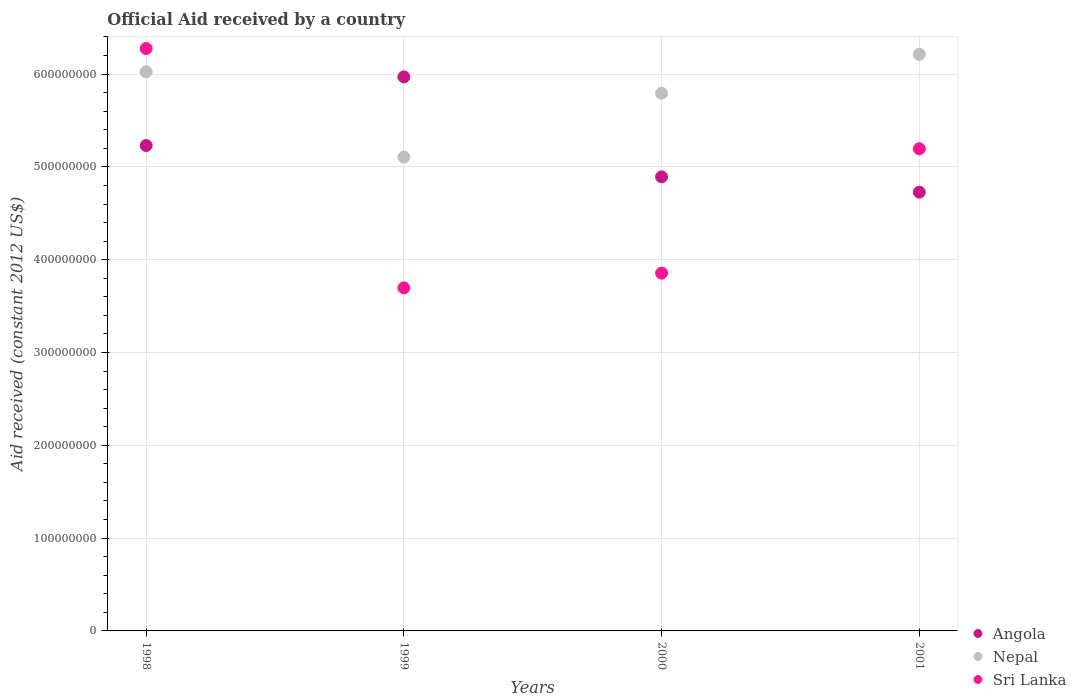What is the net official aid received in Angola in 2000?
Your answer should be compact. 4.89e+08. Across all years, what is the maximum net official aid received in Nepal?
Offer a terse response. 6.21e+08. Across all years, what is the minimum net official aid received in Sri Lanka?
Make the answer very short. 3.70e+08. In which year was the net official aid received in Sri Lanka maximum?
Make the answer very short. 1998. In which year was the net official aid received in Nepal minimum?
Your response must be concise. 1999. What is the total net official aid received in Nepal in the graph?
Your answer should be compact. 2.31e+09. What is the difference between the net official aid received in Nepal in 1998 and that in 2001?
Give a very brief answer. -1.89e+07. What is the difference between the net official aid received in Angola in 1998 and the net official aid received in Nepal in 2001?
Your answer should be compact. -9.83e+07. What is the average net official aid received in Angola per year?
Keep it short and to the point. 5.21e+08. In the year 2000, what is the difference between the net official aid received in Sri Lanka and net official aid received in Nepal?
Give a very brief answer. -1.94e+08. What is the ratio of the net official aid received in Sri Lanka in 1998 to that in 2001?
Make the answer very short. 1.21. What is the difference between the highest and the second highest net official aid received in Nepal?
Make the answer very short. 1.89e+07. What is the difference between the highest and the lowest net official aid received in Nepal?
Your answer should be very brief. 1.11e+08. Does the net official aid received in Sri Lanka monotonically increase over the years?
Make the answer very short. No. Is the net official aid received in Angola strictly less than the net official aid received in Sri Lanka over the years?
Provide a succinct answer. No. How many years are there in the graph?
Your response must be concise. 4. What is the difference between two consecutive major ticks on the Y-axis?
Your answer should be compact. 1.00e+08. Does the graph contain any zero values?
Ensure brevity in your answer.  No. Does the graph contain grids?
Your answer should be very brief. Yes. Where does the legend appear in the graph?
Offer a very short reply. Bottom right. How many legend labels are there?
Provide a succinct answer. 3. How are the legend labels stacked?
Your response must be concise. Vertical. What is the title of the graph?
Provide a short and direct response. Official Aid received by a country. What is the label or title of the Y-axis?
Give a very brief answer. Aid received (constant 2012 US$). What is the Aid received (constant 2012 US$) of Angola in 1998?
Your answer should be very brief. 5.23e+08. What is the Aid received (constant 2012 US$) in Nepal in 1998?
Keep it short and to the point. 6.02e+08. What is the Aid received (constant 2012 US$) of Sri Lanka in 1998?
Your answer should be compact. 6.28e+08. What is the Aid received (constant 2012 US$) in Angola in 1999?
Give a very brief answer. 5.97e+08. What is the Aid received (constant 2012 US$) in Nepal in 1999?
Provide a short and direct response. 5.11e+08. What is the Aid received (constant 2012 US$) in Sri Lanka in 1999?
Your response must be concise. 3.70e+08. What is the Aid received (constant 2012 US$) of Angola in 2000?
Give a very brief answer. 4.89e+08. What is the Aid received (constant 2012 US$) of Nepal in 2000?
Make the answer very short. 5.79e+08. What is the Aid received (constant 2012 US$) of Sri Lanka in 2000?
Offer a very short reply. 3.86e+08. What is the Aid received (constant 2012 US$) in Angola in 2001?
Make the answer very short. 4.73e+08. What is the Aid received (constant 2012 US$) of Nepal in 2001?
Give a very brief answer. 6.21e+08. What is the Aid received (constant 2012 US$) in Sri Lanka in 2001?
Your answer should be compact. 5.20e+08. Across all years, what is the maximum Aid received (constant 2012 US$) of Angola?
Offer a very short reply. 5.97e+08. Across all years, what is the maximum Aid received (constant 2012 US$) of Nepal?
Keep it short and to the point. 6.21e+08. Across all years, what is the maximum Aid received (constant 2012 US$) in Sri Lanka?
Offer a terse response. 6.28e+08. Across all years, what is the minimum Aid received (constant 2012 US$) in Angola?
Offer a very short reply. 4.73e+08. Across all years, what is the minimum Aid received (constant 2012 US$) of Nepal?
Make the answer very short. 5.11e+08. Across all years, what is the minimum Aid received (constant 2012 US$) of Sri Lanka?
Your answer should be very brief. 3.70e+08. What is the total Aid received (constant 2012 US$) of Angola in the graph?
Ensure brevity in your answer.  2.08e+09. What is the total Aid received (constant 2012 US$) of Nepal in the graph?
Make the answer very short. 2.31e+09. What is the total Aid received (constant 2012 US$) of Sri Lanka in the graph?
Offer a very short reply. 1.90e+09. What is the difference between the Aid received (constant 2012 US$) in Angola in 1998 and that in 1999?
Your response must be concise. -7.39e+07. What is the difference between the Aid received (constant 2012 US$) in Nepal in 1998 and that in 1999?
Your response must be concise. 9.19e+07. What is the difference between the Aid received (constant 2012 US$) of Sri Lanka in 1998 and that in 1999?
Give a very brief answer. 2.58e+08. What is the difference between the Aid received (constant 2012 US$) in Angola in 1998 and that in 2000?
Give a very brief answer. 3.38e+07. What is the difference between the Aid received (constant 2012 US$) of Nepal in 1998 and that in 2000?
Provide a succinct answer. 2.31e+07. What is the difference between the Aid received (constant 2012 US$) of Sri Lanka in 1998 and that in 2000?
Offer a terse response. 2.42e+08. What is the difference between the Aid received (constant 2012 US$) in Angola in 1998 and that in 2001?
Offer a very short reply. 5.03e+07. What is the difference between the Aid received (constant 2012 US$) in Nepal in 1998 and that in 2001?
Provide a succinct answer. -1.89e+07. What is the difference between the Aid received (constant 2012 US$) in Sri Lanka in 1998 and that in 2001?
Make the answer very short. 1.08e+08. What is the difference between the Aid received (constant 2012 US$) of Angola in 1999 and that in 2000?
Your response must be concise. 1.08e+08. What is the difference between the Aid received (constant 2012 US$) in Nepal in 1999 and that in 2000?
Offer a terse response. -6.88e+07. What is the difference between the Aid received (constant 2012 US$) of Sri Lanka in 1999 and that in 2000?
Ensure brevity in your answer.  -1.59e+07. What is the difference between the Aid received (constant 2012 US$) in Angola in 1999 and that in 2001?
Your answer should be compact. 1.24e+08. What is the difference between the Aid received (constant 2012 US$) in Nepal in 1999 and that in 2001?
Offer a very short reply. -1.11e+08. What is the difference between the Aid received (constant 2012 US$) of Sri Lanka in 1999 and that in 2001?
Keep it short and to the point. -1.50e+08. What is the difference between the Aid received (constant 2012 US$) in Angola in 2000 and that in 2001?
Your answer should be very brief. 1.65e+07. What is the difference between the Aid received (constant 2012 US$) in Nepal in 2000 and that in 2001?
Provide a succinct answer. -4.20e+07. What is the difference between the Aid received (constant 2012 US$) of Sri Lanka in 2000 and that in 2001?
Your answer should be very brief. -1.34e+08. What is the difference between the Aid received (constant 2012 US$) of Angola in 1998 and the Aid received (constant 2012 US$) of Nepal in 1999?
Offer a terse response. 1.25e+07. What is the difference between the Aid received (constant 2012 US$) in Angola in 1998 and the Aid received (constant 2012 US$) in Sri Lanka in 1999?
Make the answer very short. 1.53e+08. What is the difference between the Aid received (constant 2012 US$) of Nepal in 1998 and the Aid received (constant 2012 US$) of Sri Lanka in 1999?
Your answer should be very brief. 2.33e+08. What is the difference between the Aid received (constant 2012 US$) of Angola in 1998 and the Aid received (constant 2012 US$) of Nepal in 2000?
Offer a very short reply. -5.63e+07. What is the difference between the Aid received (constant 2012 US$) in Angola in 1998 and the Aid received (constant 2012 US$) in Sri Lanka in 2000?
Give a very brief answer. 1.38e+08. What is the difference between the Aid received (constant 2012 US$) of Nepal in 1998 and the Aid received (constant 2012 US$) of Sri Lanka in 2000?
Your answer should be compact. 2.17e+08. What is the difference between the Aid received (constant 2012 US$) in Angola in 1998 and the Aid received (constant 2012 US$) in Nepal in 2001?
Your answer should be very brief. -9.83e+07. What is the difference between the Aid received (constant 2012 US$) in Angola in 1998 and the Aid received (constant 2012 US$) in Sri Lanka in 2001?
Ensure brevity in your answer.  3.51e+06. What is the difference between the Aid received (constant 2012 US$) in Nepal in 1998 and the Aid received (constant 2012 US$) in Sri Lanka in 2001?
Offer a very short reply. 8.29e+07. What is the difference between the Aid received (constant 2012 US$) in Angola in 1999 and the Aid received (constant 2012 US$) in Nepal in 2000?
Keep it short and to the point. 1.76e+07. What is the difference between the Aid received (constant 2012 US$) of Angola in 1999 and the Aid received (constant 2012 US$) of Sri Lanka in 2000?
Make the answer very short. 2.11e+08. What is the difference between the Aid received (constant 2012 US$) of Nepal in 1999 and the Aid received (constant 2012 US$) of Sri Lanka in 2000?
Provide a short and direct response. 1.25e+08. What is the difference between the Aid received (constant 2012 US$) in Angola in 1999 and the Aid received (constant 2012 US$) in Nepal in 2001?
Keep it short and to the point. -2.44e+07. What is the difference between the Aid received (constant 2012 US$) in Angola in 1999 and the Aid received (constant 2012 US$) in Sri Lanka in 2001?
Your answer should be very brief. 7.74e+07. What is the difference between the Aid received (constant 2012 US$) in Nepal in 1999 and the Aid received (constant 2012 US$) in Sri Lanka in 2001?
Give a very brief answer. -8.98e+06. What is the difference between the Aid received (constant 2012 US$) in Angola in 2000 and the Aid received (constant 2012 US$) in Nepal in 2001?
Give a very brief answer. -1.32e+08. What is the difference between the Aid received (constant 2012 US$) in Angola in 2000 and the Aid received (constant 2012 US$) in Sri Lanka in 2001?
Keep it short and to the point. -3.02e+07. What is the difference between the Aid received (constant 2012 US$) in Nepal in 2000 and the Aid received (constant 2012 US$) in Sri Lanka in 2001?
Your answer should be very brief. 5.98e+07. What is the average Aid received (constant 2012 US$) in Angola per year?
Ensure brevity in your answer.  5.21e+08. What is the average Aid received (constant 2012 US$) of Nepal per year?
Provide a succinct answer. 5.78e+08. What is the average Aid received (constant 2012 US$) in Sri Lanka per year?
Your answer should be very brief. 4.76e+08. In the year 1998, what is the difference between the Aid received (constant 2012 US$) of Angola and Aid received (constant 2012 US$) of Nepal?
Offer a very short reply. -7.94e+07. In the year 1998, what is the difference between the Aid received (constant 2012 US$) in Angola and Aid received (constant 2012 US$) in Sri Lanka?
Ensure brevity in your answer.  -1.04e+08. In the year 1998, what is the difference between the Aid received (constant 2012 US$) in Nepal and Aid received (constant 2012 US$) in Sri Lanka?
Your response must be concise. -2.51e+07. In the year 1999, what is the difference between the Aid received (constant 2012 US$) of Angola and Aid received (constant 2012 US$) of Nepal?
Your answer should be very brief. 8.64e+07. In the year 1999, what is the difference between the Aid received (constant 2012 US$) in Angola and Aid received (constant 2012 US$) in Sri Lanka?
Provide a succinct answer. 2.27e+08. In the year 1999, what is the difference between the Aid received (constant 2012 US$) in Nepal and Aid received (constant 2012 US$) in Sri Lanka?
Your response must be concise. 1.41e+08. In the year 2000, what is the difference between the Aid received (constant 2012 US$) in Angola and Aid received (constant 2012 US$) in Nepal?
Provide a succinct answer. -9.01e+07. In the year 2000, what is the difference between the Aid received (constant 2012 US$) of Angola and Aid received (constant 2012 US$) of Sri Lanka?
Provide a short and direct response. 1.04e+08. In the year 2000, what is the difference between the Aid received (constant 2012 US$) of Nepal and Aid received (constant 2012 US$) of Sri Lanka?
Your response must be concise. 1.94e+08. In the year 2001, what is the difference between the Aid received (constant 2012 US$) of Angola and Aid received (constant 2012 US$) of Nepal?
Your answer should be very brief. -1.49e+08. In the year 2001, what is the difference between the Aid received (constant 2012 US$) of Angola and Aid received (constant 2012 US$) of Sri Lanka?
Ensure brevity in your answer.  -4.68e+07. In the year 2001, what is the difference between the Aid received (constant 2012 US$) of Nepal and Aid received (constant 2012 US$) of Sri Lanka?
Keep it short and to the point. 1.02e+08. What is the ratio of the Aid received (constant 2012 US$) in Angola in 1998 to that in 1999?
Offer a very short reply. 0.88. What is the ratio of the Aid received (constant 2012 US$) in Nepal in 1998 to that in 1999?
Your answer should be compact. 1.18. What is the ratio of the Aid received (constant 2012 US$) in Sri Lanka in 1998 to that in 1999?
Ensure brevity in your answer.  1.7. What is the ratio of the Aid received (constant 2012 US$) of Angola in 1998 to that in 2000?
Your answer should be compact. 1.07. What is the ratio of the Aid received (constant 2012 US$) of Nepal in 1998 to that in 2000?
Keep it short and to the point. 1.04. What is the ratio of the Aid received (constant 2012 US$) in Sri Lanka in 1998 to that in 2000?
Provide a succinct answer. 1.63. What is the ratio of the Aid received (constant 2012 US$) of Angola in 1998 to that in 2001?
Your answer should be compact. 1.11. What is the ratio of the Aid received (constant 2012 US$) of Nepal in 1998 to that in 2001?
Make the answer very short. 0.97. What is the ratio of the Aid received (constant 2012 US$) of Sri Lanka in 1998 to that in 2001?
Give a very brief answer. 1.21. What is the ratio of the Aid received (constant 2012 US$) of Angola in 1999 to that in 2000?
Your answer should be compact. 1.22. What is the ratio of the Aid received (constant 2012 US$) in Nepal in 1999 to that in 2000?
Offer a terse response. 0.88. What is the ratio of the Aid received (constant 2012 US$) in Sri Lanka in 1999 to that in 2000?
Offer a very short reply. 0.96. What is the ratio of the Aid received (constant 2012 US$) in Angola in 1999 to that in 2001?
Give a very brief answer. 1.26. What is the ratio of the Aid received (constant 2012 US$) of Nepal in 1999 to that in 2001?
Offer a very short reply. 0.82. What is the ratio of the Aid received (constant 2012 US$) in Sri Lanka in 1999 to that in 2001?
Your answer should be very brief. 0.71. What is the ratio of the Aid received (constant 2012 US$) of Angola in 2000 to that in 2001?
Your response must be concise. 1.03. What is the ratio of the Aid received (constant 2012 US$) in Nepal in 2000 to that in 2001?
Offer a terse response. 0.93. What is the ratio of the Aid received (constant 2012 US$) of Sri Lanka in 2000 to that in 2001?
Offer a very short reply. 0.74. What is the difference between the highest and the second highest Aid received (constant 2012 US$) of Angola?
Your response must be concise. 7.39e+07. What is the difference between the highest and the second highest Aid received (constant 2012 US$) in Nepal?
Offer a terse response. 1.89e+07. What is the difference between the highest and the second highest Aid received (constant 2012 US$) in Sri Lanka?
Ensure brevity in your answer.  1.08e+08. What is the difference between the highest and the lowest Aid received (constant 2012 US$) in Angola?
Your response must be concise. 1.24e+08. What is the difference between the highest and the lowest Aid received (constant 2012 US$) of Nepal?
Provide a succinct answer. 1.11e+08. What is the difference between the highest and the lowest Aid received (constant 2012 US$) of Sri Lanka?
Give a very brief answer. 2.58e+08. 